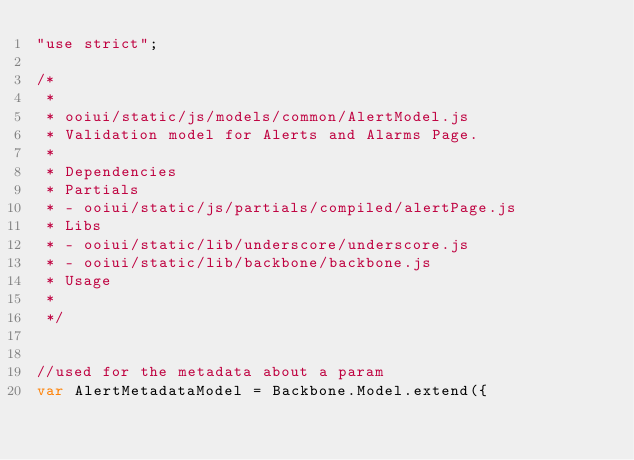<code> <loc_0><loc_0><loc_500><loc_500><_JavaScript_>"use strict";

/*
 * 
 * ooiui/static/js/models/common/AlertModel.js
 * Validation model for Alerts and Alarms Page.
 *
 * Dependencies
 * Partials
 * - ooiui/static/js/partials/compiled/alertPage.js
 * Libs
 * - ooiui/static/lib/underscore/underscore.js
 * - ooiui/static/lib/backbone/backbone.js
 * Usage
 * 
 */


//used for the metadata about a param
var AlertMetadataModel = Backbone.Model.extend({</code> 